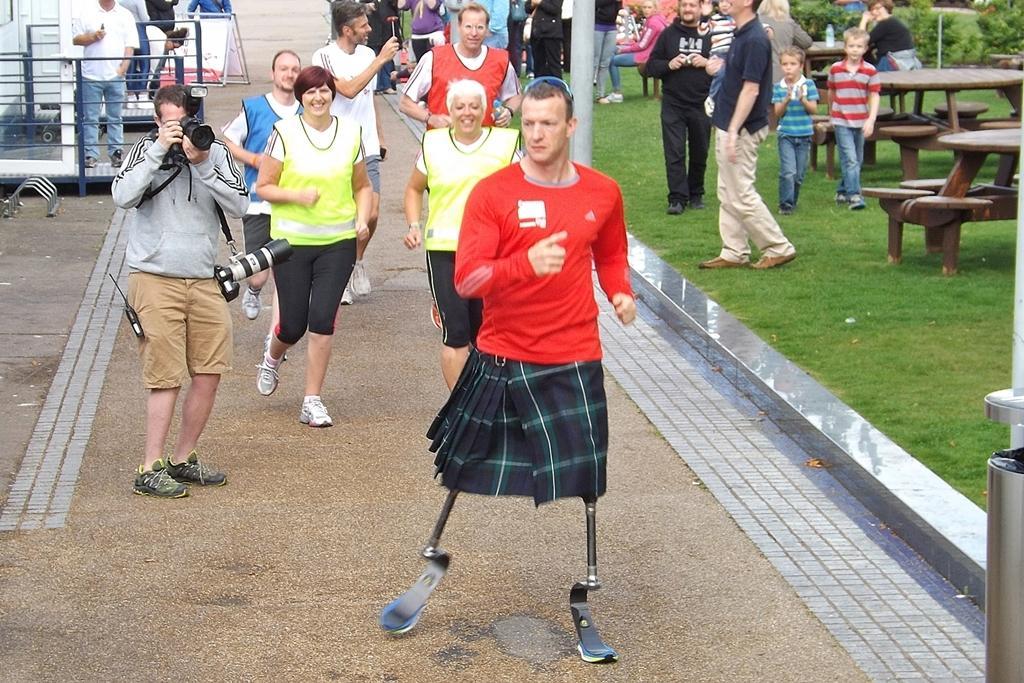In one or two sentences, can you explain what this image depicts? Here we see a group of people running and person standing and taking photograph with a camera and we see benches and a person running with artificial legs. 